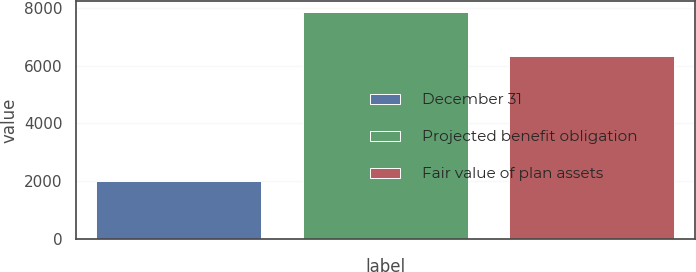Convert chart. <chart><loc_0><loc_0><loc_500><loc_500><bar_chart><fcel>December 31<fcel>Projected benefit obligation<fcel>Fair value of plan assets<nl><fcel>2017<fcel>7833<fcel>6330<nl></chart> 